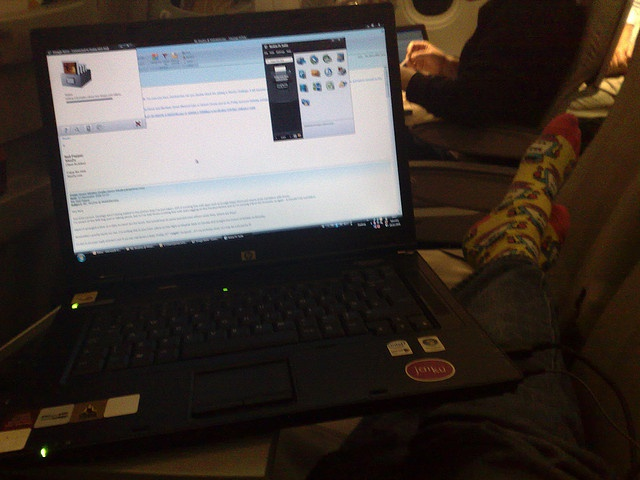Describe the objects in this image and their specific colors. I can see laptop in olive, black, lightgray, and darkgray tones, people in olive, black, and maroon tones, people in olive, black, maroon, and brown tones, and chair in olive, black, and maroon tones in this image. 